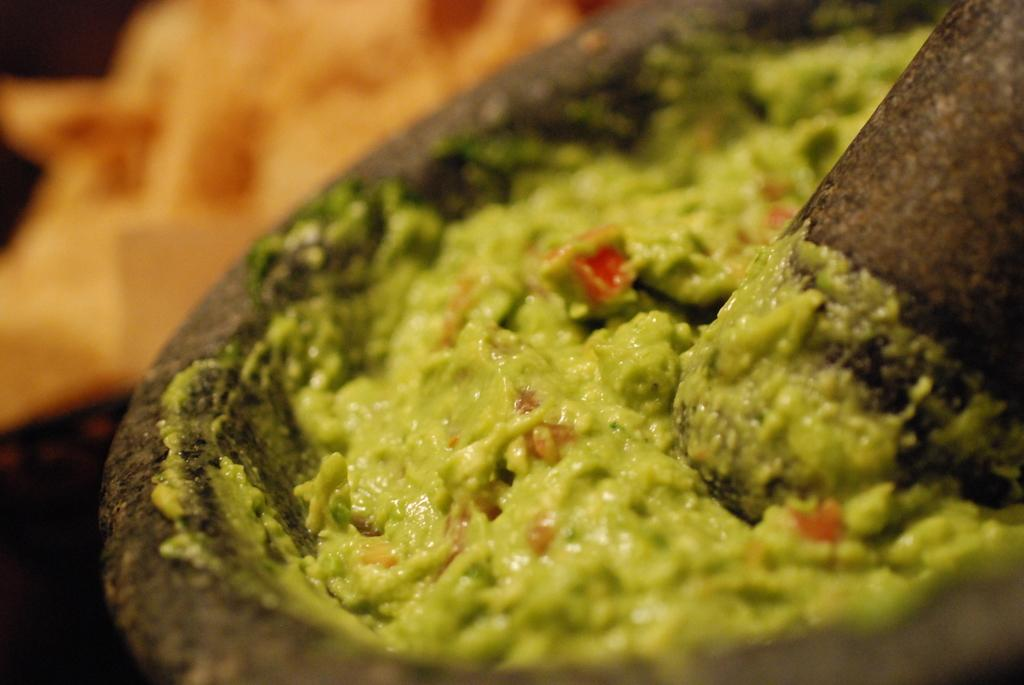What type of food item is visible in the image? The food item in the image is green in color. What object is used for grinding in the image? There is a grinding stone in the image. Can you describe the background of the image? The background of the image is blurry. What legal advice is the lawyer providing in the image? There is no lawyer present in the image, so no legal advice can be provided. 